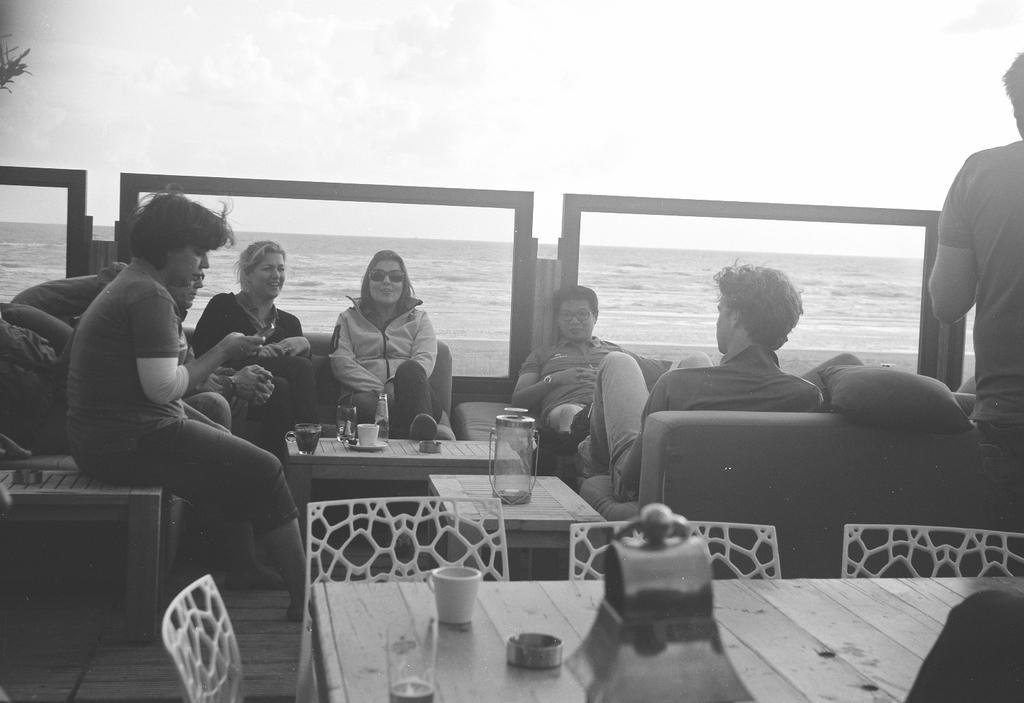Describe this image in one or two sentences. There is a group of people. They are sitting in a sofa. There is a table. There is a glass,plate,saucer and jar on a table. We can see the background there is a beautiful sea and sky. 